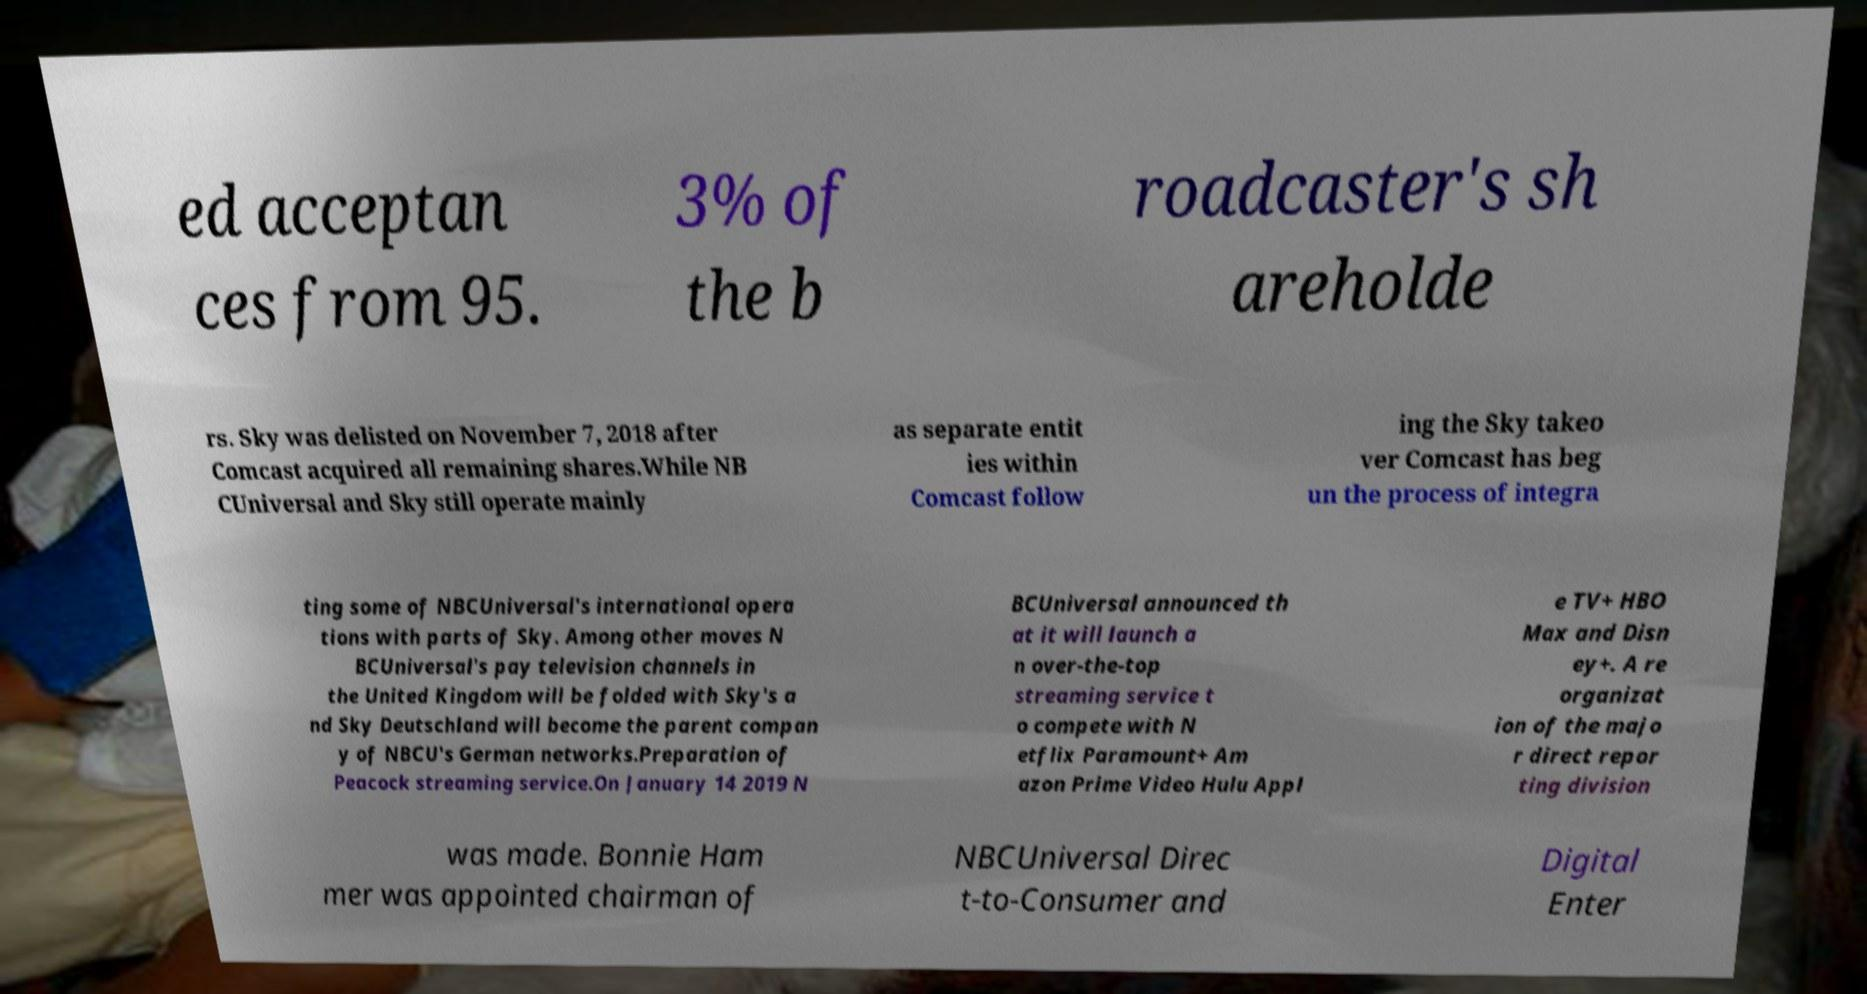Can you accurately transcribe the text from the provided image for me? ed acceptan ces from 95. 3% of the b roadcaster's sh areholde rs. Sky was delisted on November 7, 2018 after Comcast acquired all remaining shares.While NB CUniversal and Sky still operate mainly as separate entit ies within Comcast follow ing the Sky takeo ver Comcast has beg un the process of integra ting some of NBCUniversal's international opera tions with parts of Sky. Among other moves N BCUniversal's pay television channels in the United Kingdom will be folded with Sky's a nd Sky Deutschland will become the parent compan y of NBCU's German networks.Preparation of Peacock streaming service.On January 14 2019 N BCUniversal announced th at it will launch a n over-the-top streaming service t o compete with N etflix Paramount+ Am azon Prime Video Hulu Appl e TV+ HBO Max and Disn ey+. A re organizat ion of the majo r direct repor ting division was made. Bonnie Ham mer was appointed chairman of NBCUniversal Direc t-to-Consumer and Digital Enter 